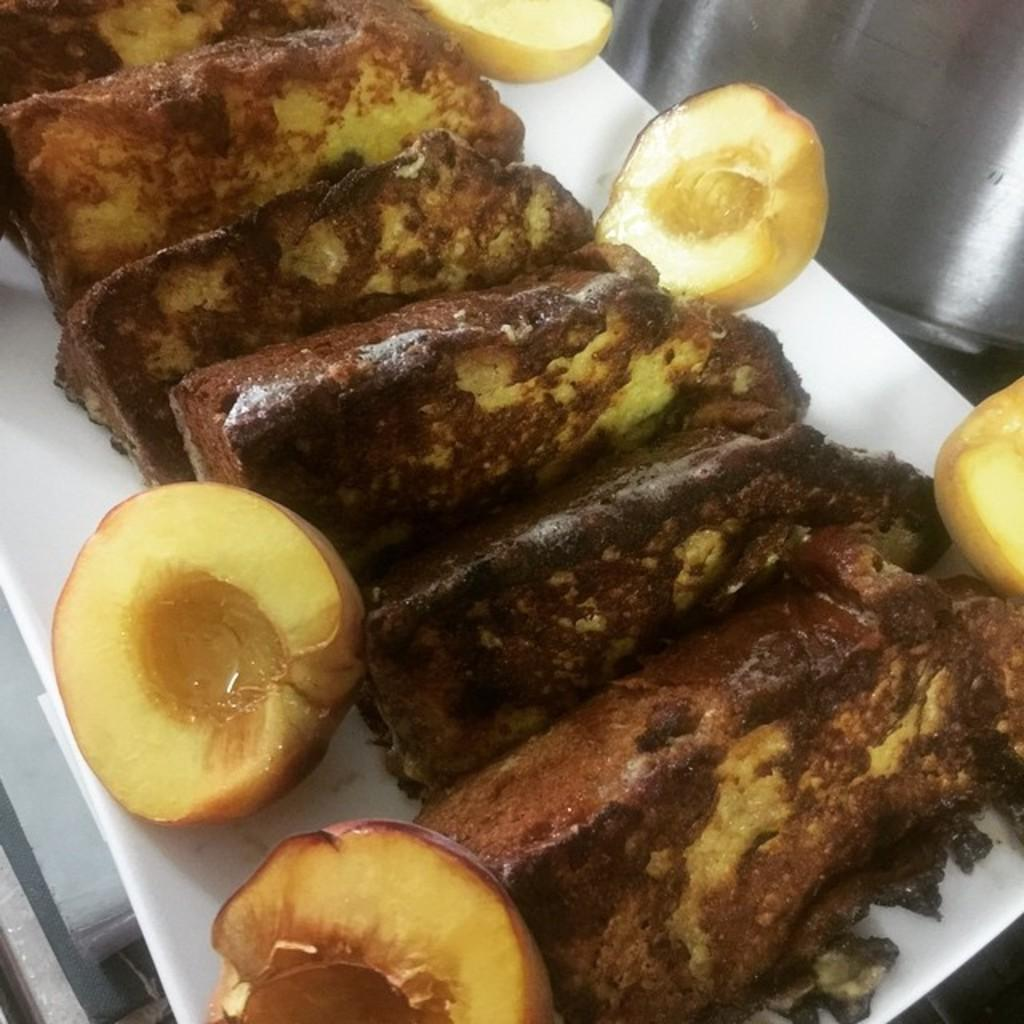What is present in the image related to food? There are food items in the image. How are the food items arranged or placed in the image? The food items are in a plate. Where is the plate with food items located in the image? The plate is located in the center of the image. What type of harmony can be heard between the food items in the image? There is no audible harmony present in the image, as it features food items in a plate. 